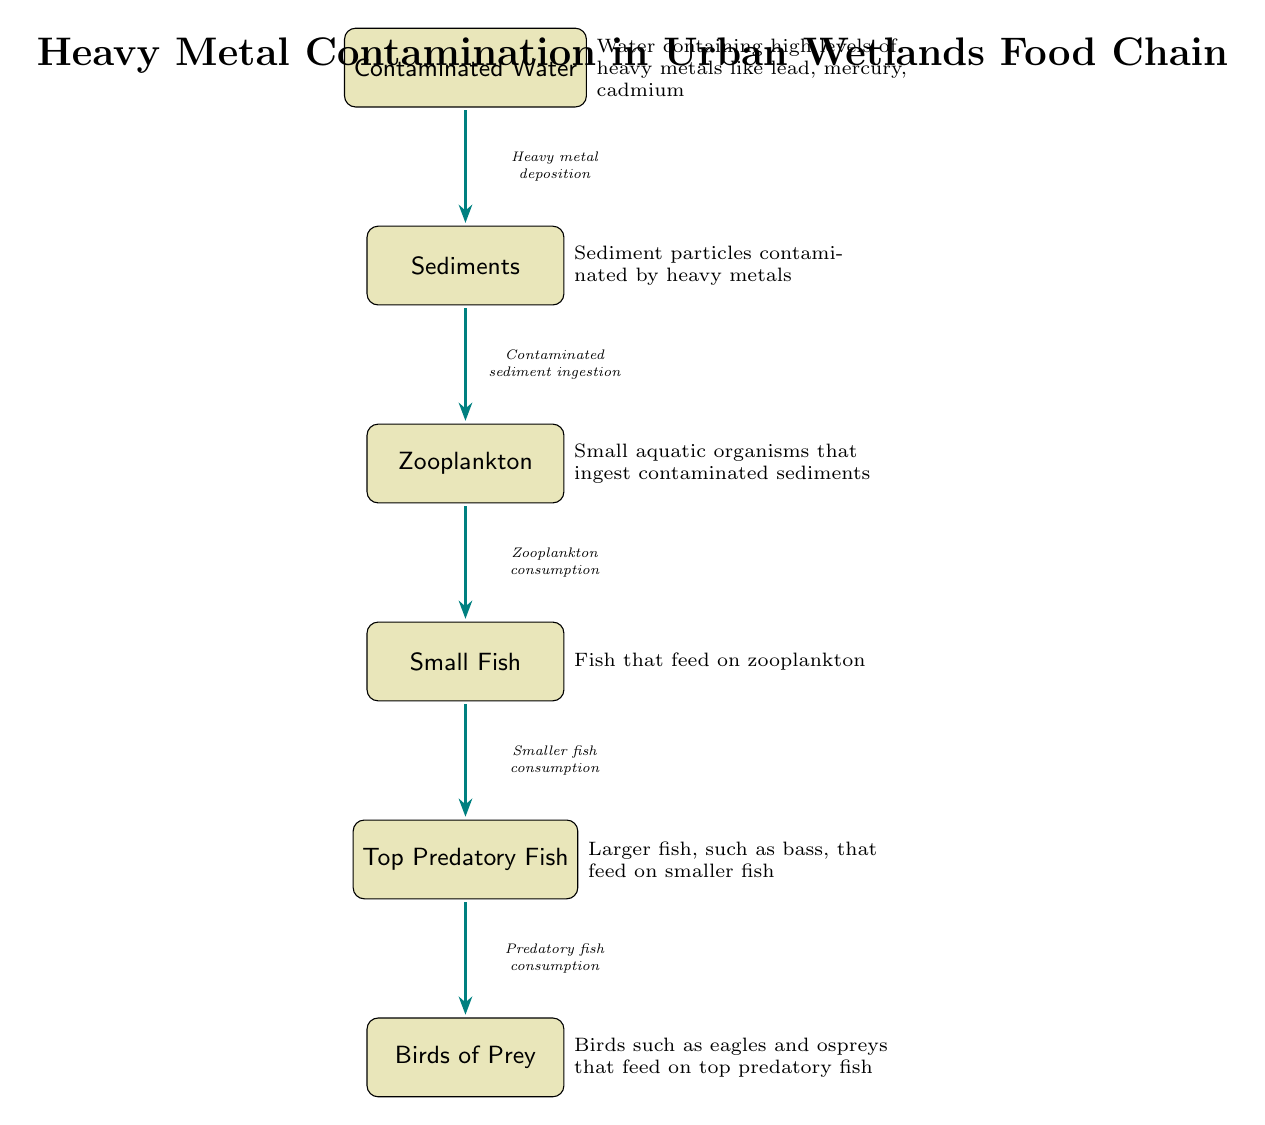What is the first node in the food chain? The first node is "Contaminated Water," which indicates that the chain begins with the source of heavy metal contamination.
Answer: Contaminated Water Which node comes after Sediments? The node that follows "Sediments" is "Zooplankton," indicating the next level in the food chain where zooplankton feed on contaminated sediment.
Answer: Zooplankton How many nodes are present in this food chain? The diagram shows a total of 6 nodes, which represent different stages in the food chain affected by heavy metals.
Answer: 6 What type of fish is indicated as the top predator in the food chain? The top predator in the food chain is referred to as "Birds of Prey," specifically indicating that the chain culminates in birds eating predatory fish.
Answer: Birds of Prey What is the relationship between Zooplankton and Small Fish? The relationship is that "Zooplankton consumption" leads to "Small Fish," meaning small fish feed on zooplankton, which is directly influenced by contamination.
Answer: Zooplankton consumption What contaminates the Sediments in the food chain? The Sediments are contaminated by "Heavy metal deposition," which indicates the source of the pollution affecting the aquatic ecosystem.
Answer: Heavy metal deposition What do Top Predatory Fish consume in this food chain? Top Predatory Fish consume "Smaller fish," which indicates the dietary behaviors of larger fish in the food web.
Answer: Smaller fish What affects fish populations in this diagram? Fish populations are affected by "Contaminated sediment ingestion," indicating how pollutants move through the food chain, impacting species at different levels.
Answer: Contaminated sediment ingestion Which arrows indicate the flow of contamination through the food chain? All arrows in the diagram represent the flow of contamination and subsequent consumption throughout the food chain, starting from contaminated water to birds of prey.
Answer: All arrows 